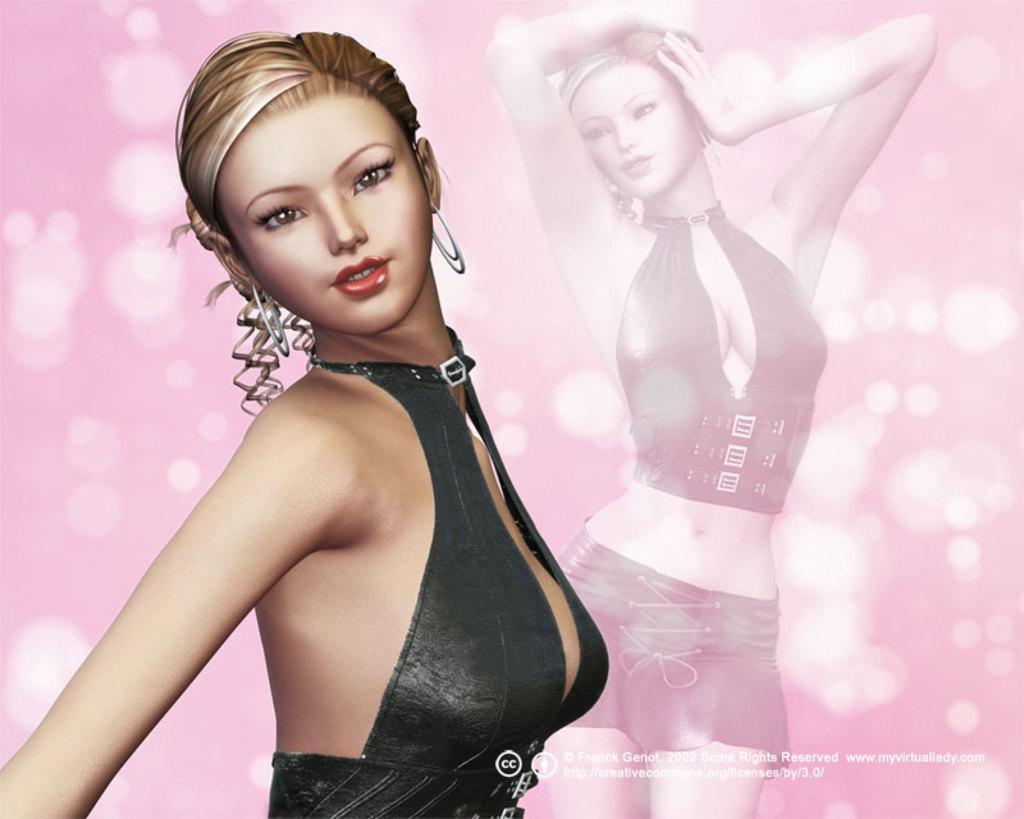How would you summarize this image in a sentence or two? In this image, we can see a woman statue and in the background, we can see a poster. 